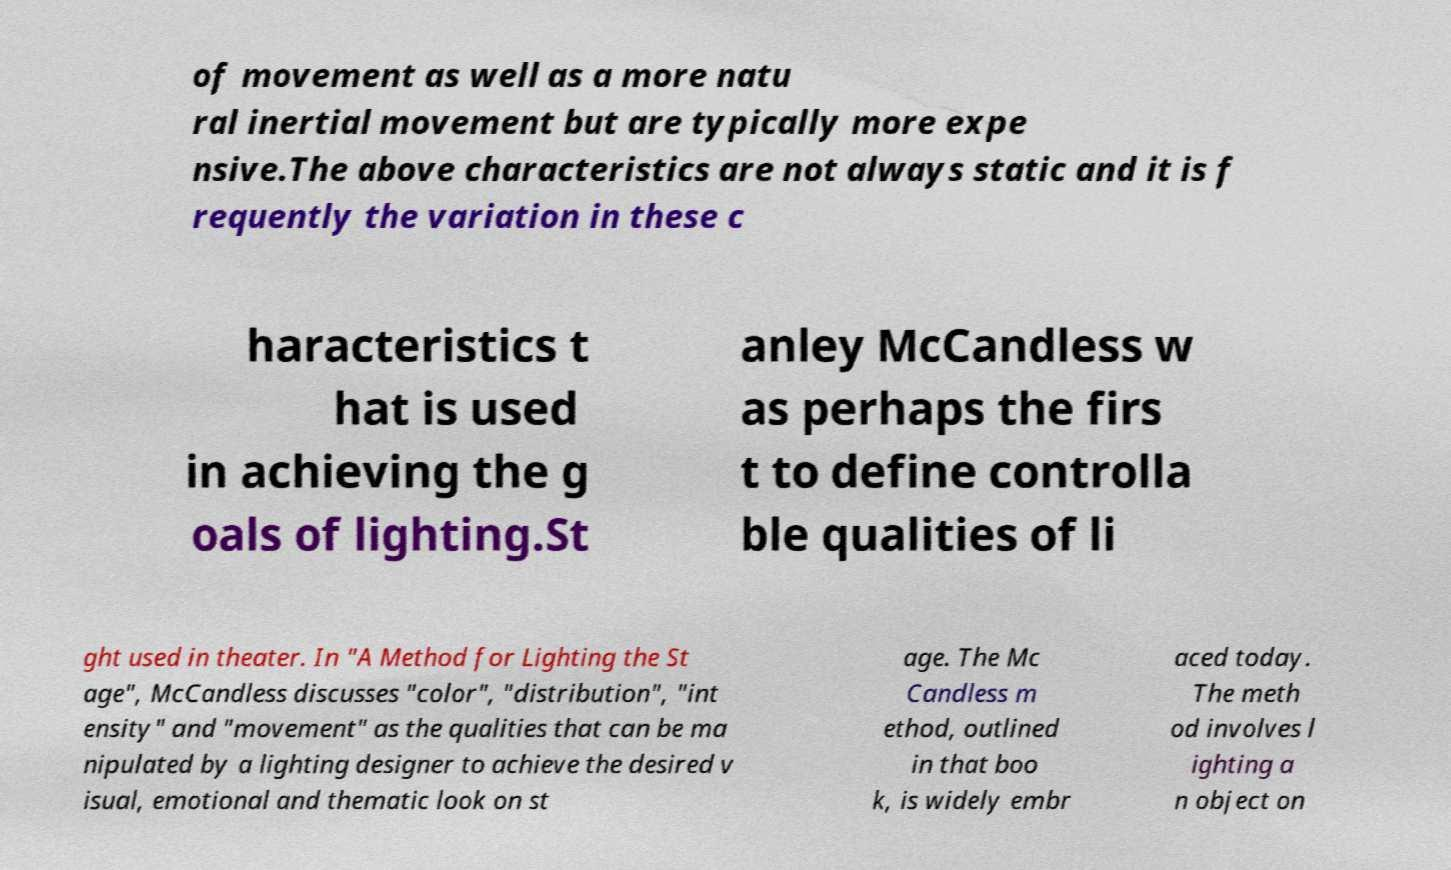What messages or text are displayed in this image? I need them in a readable, typed format. of movement as well as a more natu ral inertial movement but are typically more expe nsive.The above characteristics are not always static and it is f requently the variation in these c haracteristics t hat is used in achieving the g oals of lighting.St anley McCandless w as perhaps the firs t to define controlla ble qualities of li ght used in theater. In "A Method for Lighting the St age", McCandless discusses "color", "distribution", "int ensity" and "movement" as the qualities that can be ma nipulated by a lighting designer to achieve the desired v isual, emotional and thematic look on st age. The Mc Candless m ethod, outlined in that boo k, is widely embr aced today. The meth od involves l ighting a n object on 